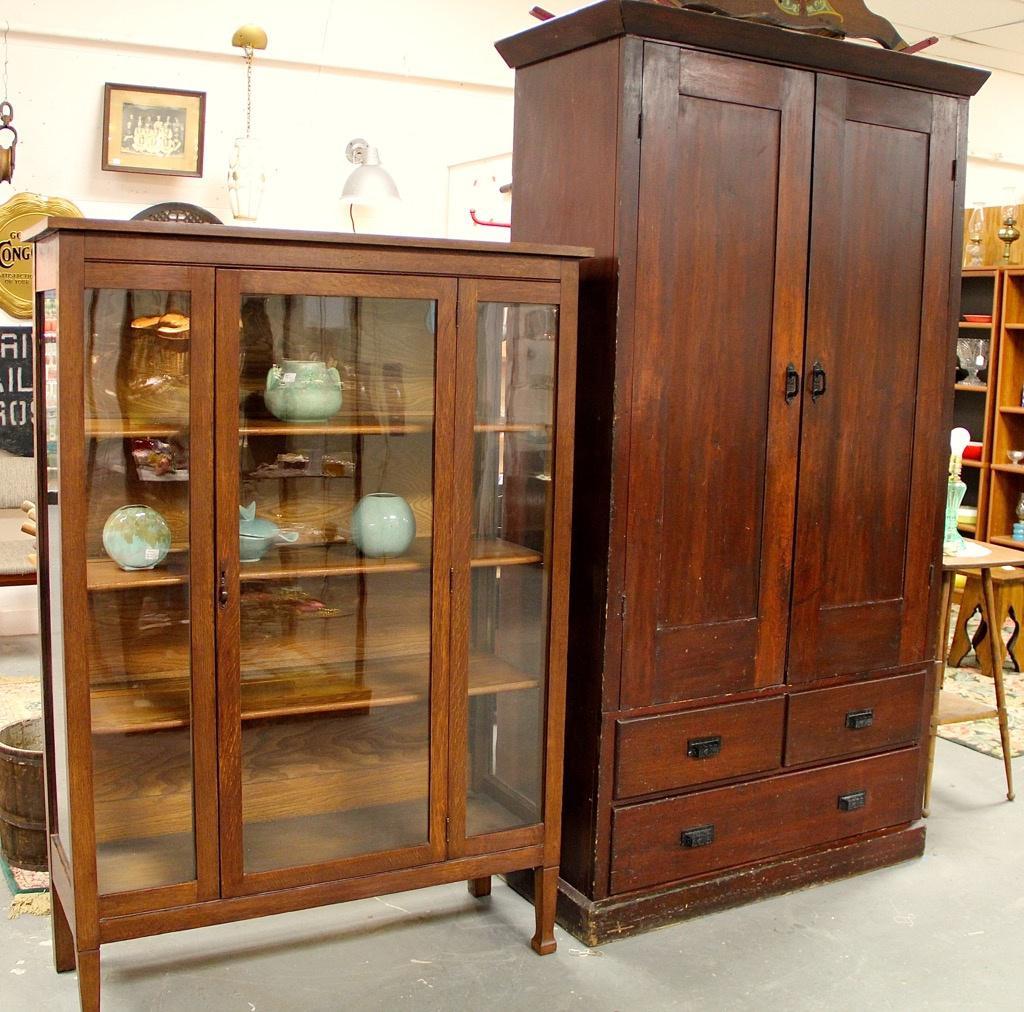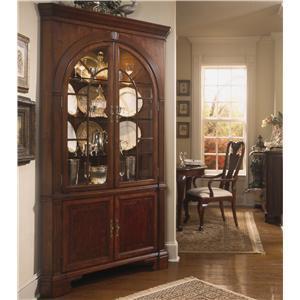The first image is the image on the left, the second image is the image on the right. Evaluate the accuracy of this statement regarding the images: "At least two round plates are clearly visible in the image on the right.". Is it true? Answer yes or no. Yes. 